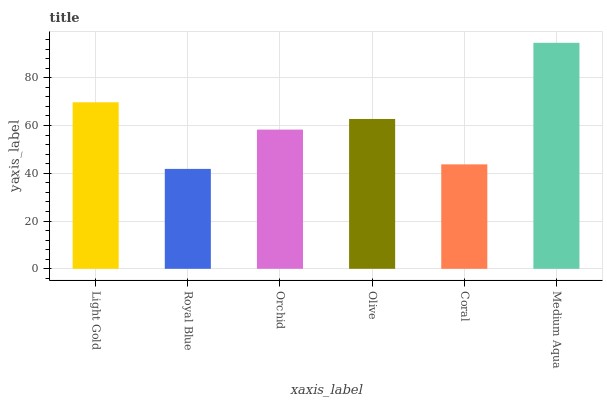Is Royal Blue the minimum?
Answer yes or no. Yes. Is Medium Aqua the maximum?
Answer yes or no. Yes. Is Orchid the minimum?
Answer yes or no. No. Is Orchid the maximum?
Answer yes or no. No. Is Orchid greater than Royal Blue?
Answer yes or no. Yes. Is Royal Blue less than Orchid?
Answer yes or no. Yes. Is Royal Blue greater than Orchid?
Answer yes or no. No. Is Orchid less than Royal Blue?
Answer yes or no. No. Is Olive the high median?
Answer yes or no. Yes. Is Orchid the low median?
Answer yes or no. Yes. Is Light Gold the high median?
Answer yes or no. No. Is Medium Aqua the low median?
Answer yes or no. No. 